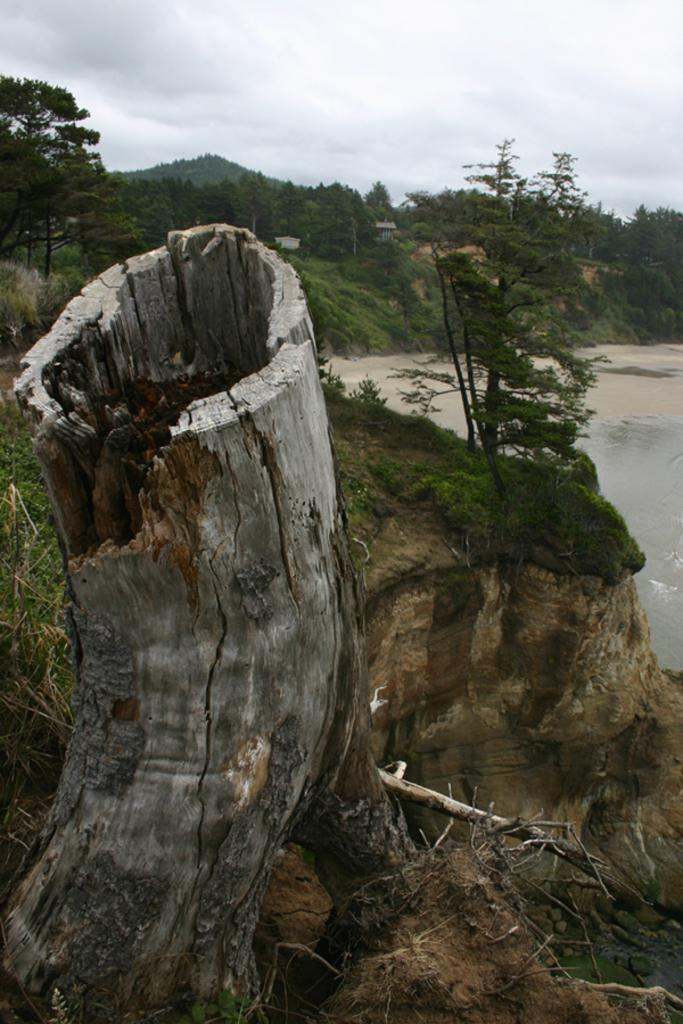What is the main subject of the image? The main subject of the image is the bark of a tree. What can be seen in the background of the image? There is greenery and a water body in the background of the image. What is visible at the top of the image? The sky is visible at the top of the image. What can be observed in the sky? Clouds are present in the sky. What type of debt is being discussed in the image? There is no mention of debt in the image; it features the bark of a tree, greenery, a water body, the sky, and clouds. What type of stew is being prepared in the image? There is no stew or cooking activity present in the image. 